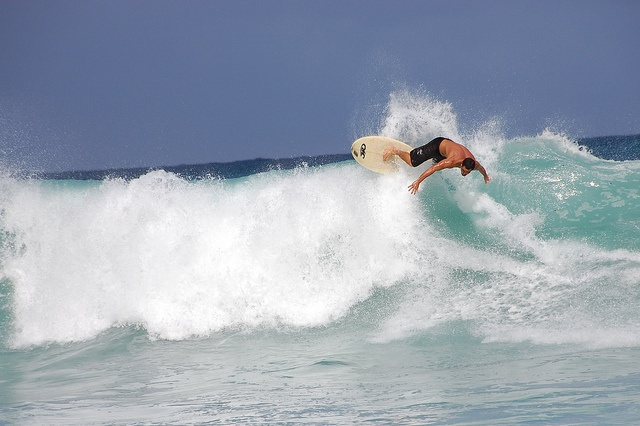Describe the objects in this image and their specific colors. I can see people in gray, black, red, brown, and darkgray tones and surfboard in gray, tan, lightgray, and darkgray tones in this image. 